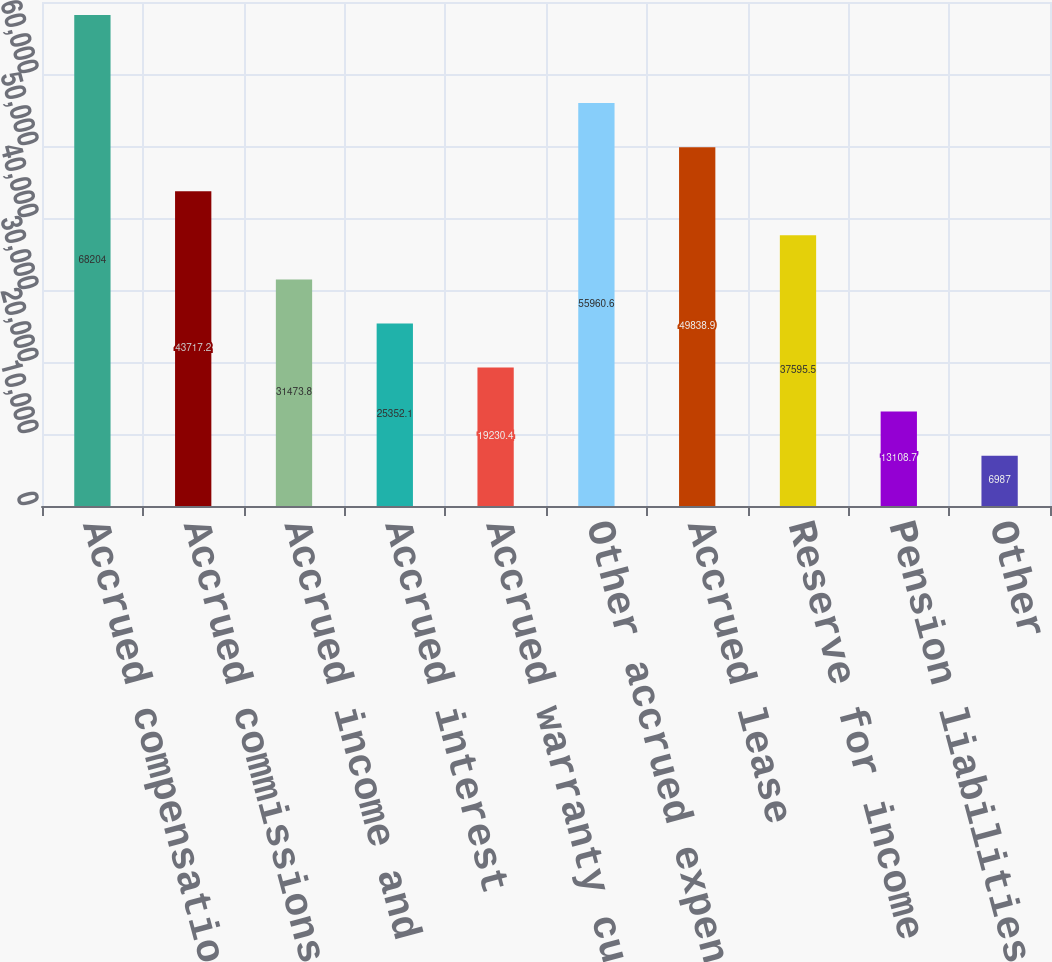Convert chart. <chart><loc_0><loc_0><loc_500><loc_500><bar_chart><fcel>Accrued compensation and<fcel>Accrued commissions<fcel>Accrued income and other taxes<fcel>Accrued interest<fcel>Accrued warranty current<fcel>Other accrued expenses<fcel>Accrued lease<fcel>Reserve for income tax<fcel>Pension liabilities-long-term<fcel>Other<nl><fcel>68204<fcel>43717.2<fcel>31473.8<fcel>25352.1<fcel>19230.4<fcel>55960.6<fcel>49838.9<fcel>37595.5<fcel>13108.7<fcel>6987<nl></chart> 